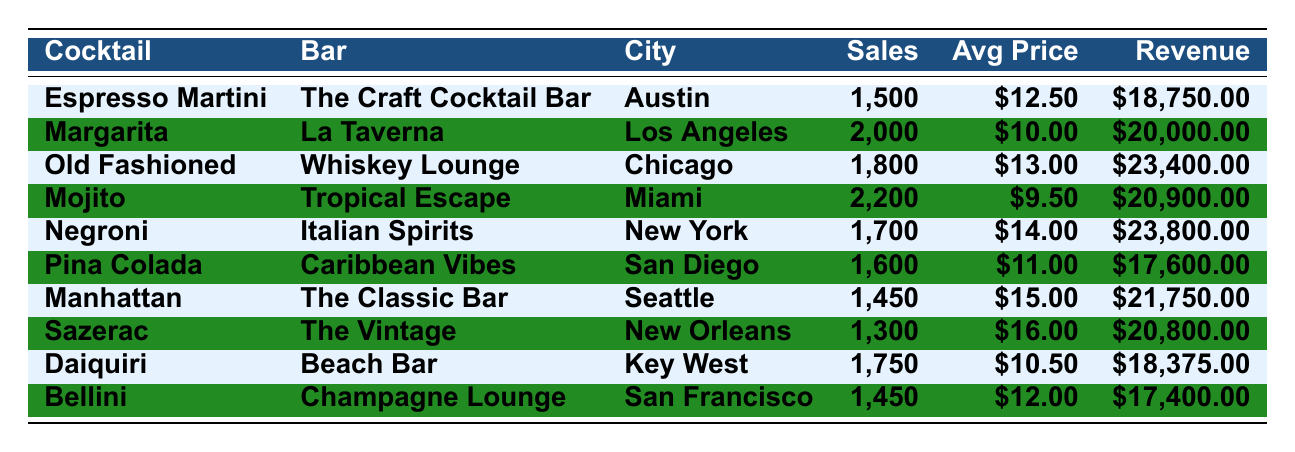What cocktail had the highest total revenue? The total revenue for each cocktail can be compared: Espresso Martini ($18,750), Margarita ($20,000), Old Fashioned ($23,400), Mojito ($20,900), Negroni ($23,800), Pina Colada ($17,600), Manhattan ($21,750), Sazerac ($20,800), Daiquiri ($18,375), and Bellini ($17,400). The highest total revenue is for the Negroni at $23,800.
Answer: Negroni Which cocktail sold the least units? The sales units for each cocktail are compared: Espresso Martini (1,500), Margarita (2,000), Old Fashioned (1,800), Mojito (2,200), Negroni (1,700), Pina Colada (1,600), Manhattan (1,450), Sazerac (1,300), Daiquiri (1,750), and Bellini (1,450). The Sazerac has the least units sold at 1,300.
Answer: Sazerac What is the average price of all cocktails listed? To find the average price, we add the average prices: $12.50 + $10.00 + $13.00 + $9.50 + $14.00 + $11.00 + $15.00 + $16.00 + $10.50 + $12.00 = $  12.30, and then divide by the number of cocktails, which is 10. Therefore, the average price is $12.30.
Answer: $12.30 Which city had the most cocktail sales units combined? We can sum the total sales units: Austin (1,500), Los Angeles (2,000), Chicago (1,800), Miami (2,200), New York (1,700), San Diego (1,600), Seattle (1,450), New Orleans (1,300), Key West (1,750), San Francisco (1,450). Adding all these gives us a total of  15,750 units. So, rather than looking for cities with high performance individually, we directly compute totals if needed for comparisons among city performance.
Answer: 15,750 How much more revenue did the Mojito generate compared to the Sazerac? The revenue from Mojito is $20,900 and from Sazerac is $20,800. To find the difference, subtract: $20,900 - $20,800 = $100.
Answer: $100 Which cocktail had both high sales units and high average price? To check for high sales units, we find the cocktails with the highest figures: Mojito (2,200) and Margarita (2,000). For the price, both of these cocktails have average prices below $13. Looking for any cocktail with high sales and price leads us to Negroni (1,700) priced at $14.00, thus standing out in its performance.
Answer: Negroni 